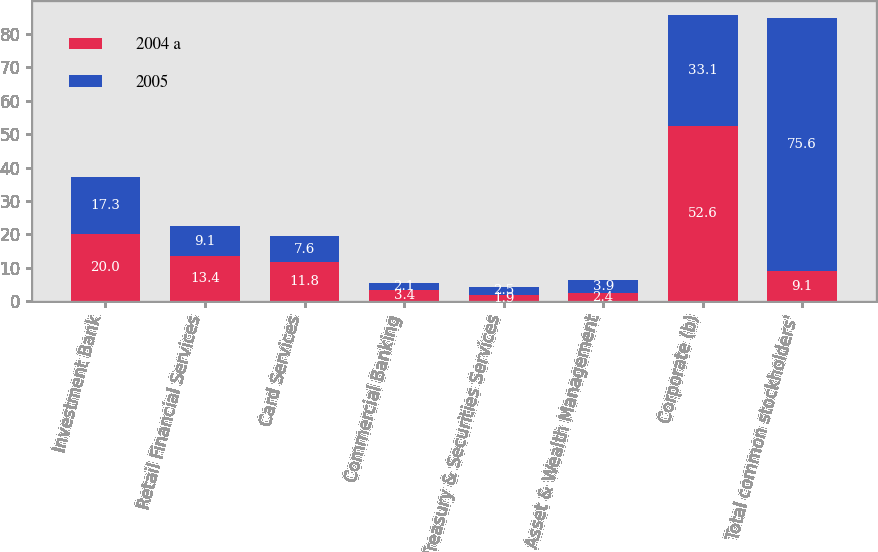<chart> <loc_0><loc_0><loc_500><loc_500><stacked_bar_chart><ecel><fcel>Investment Bank<fcel>Retail Financial Services<fcel>Card Services<fcel>Commercial Banking<fcel>Treasury & Securities Services<fcel>Asset & Wealth Management<fcel>Corporate (b)<fcel>Total common stockholders'<nl><fcel>2004 a<fcel>20<fcel>13.4<fcel>11.8<fcel>3.4<fcel>1.9<fcel>2.4<fcel>52.6<fcel>9.1<nl><fcel>2005<fcel>17.3<fcel>9.1<fcel>7.6<fcel>2.1<fcel>2.5<fcel>3.9<fcel>33.1<fcel>75.6<nl></chart> 